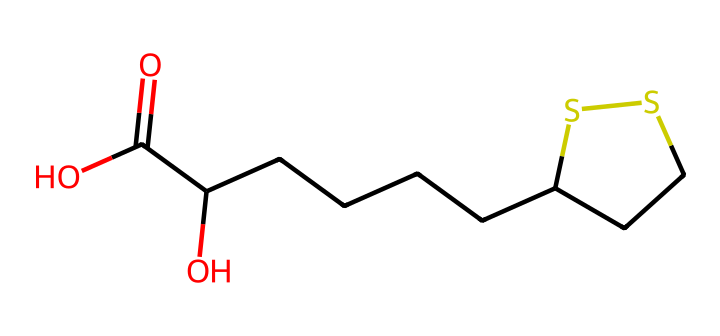What is the molecular formula of alpha-lipoic acid? To determine the molecular formula, count the number of each type of atom in the chemical structure. From the SMILES representation, it contains carbon (C), oxygen (O), and sulfur (S) atoms. The full count results in a formula of C8H14O2S2.
Answer: C8H14O2S2 How many oxygen atoms are present in this compound? The SMILES indicates two "O" letters, which represent the oxygen atoms in the molecular structure. Thus, we can conclude that there are two oxygen atoms.
Answer: 2 What functional groups are present in alpha-lipoic acid? Identifying the functional groups from the structure shows that it contains a carboxylic acid group (due to the -COOH seen in the structure) and a thio ether group (represented by the -S- groups).
Answer: carboxylic acid, thio ether Is alpha-lipoic acid a saturated or unsaturated compound? Looking at the structure, there are no double or triple bonds present in the carbon chain, indicating that all carbon atoms are single bonded. Therefore, it is a saturated compound.
Answer: saturated How many carbon atoms are in alpha-lipoic acid? By examining the structure, we count the number of "C" symbols in the SMILES. This shows there are a total of 8 carbon atoms present in the molecule.
Answer: 8 What is the charge of the alpha-lipoic acid molecule? The SMILES does not indicate any charges. In the context of organic molecules, alpha-lipoic acid is neutral, as there are no charged atoms or ions present in its structure.
Answer: neutral 